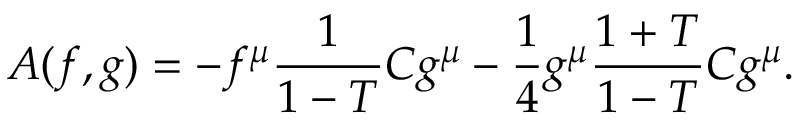Convert formula to latex. <formula><loc_0><loc_0><loc_500><loc_500>A ( f , g ) = - f ^ { \mu } \frac { 1 } { 1 - T } C g ^ { \mu } - \frac { 1 } { 4 } g ^ { \mu } \frac { 1 + T } { 1 - T } C g ^ { \mu } .</formula> 